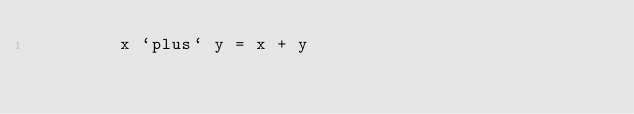<code> <loc_0><loc_0><loc_500><loc_500><_Haskell_>        x `plus` y = x + y
</code> 